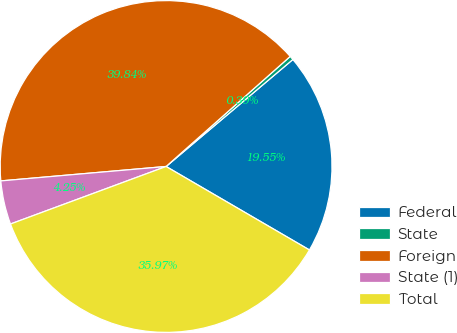<chart> <loc_0><loc_0><loc_500><loc_500><pie_chart><fcel>Federal<fcel>State<fcel>Foreign<fcel>State (1)<fcel>Total<nl><fcel>19.55%<fcel>0.39%<fcel>39.84%<fcel>4.25%<fcel>35.97%<nl></chart> 